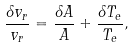<formula> <loc_0><loc_0><loc_500><loc_500>\frac { \delta v _ { r } } { v _ { r } } = \frac { \delta A } { A } + \frac { \delta T _ { e } } { T _ { e } } ,</formula> 